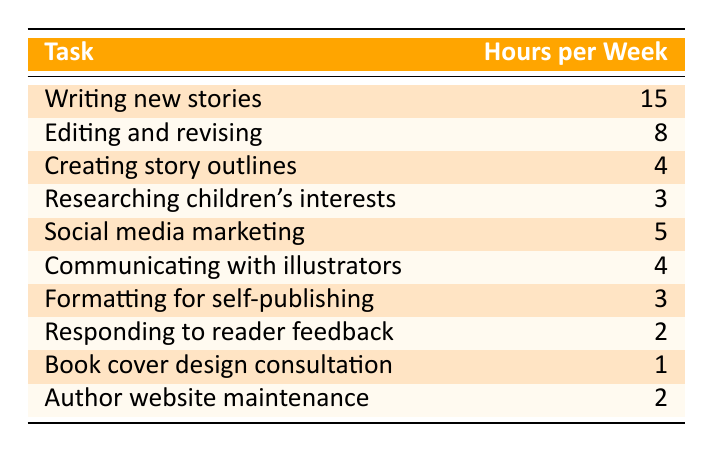What task requires the most hours per week? Referring to the table, the task with the highest hours is "Writing new stories," which takes 15 hours per week.
Answer: 15 hours How many hours do you spend on editing and revising each week? The table indicates that "Editing and revising" takes 8 hours per week.
Answer: 8 hours What is the combined time spent on creating story outlines and formatting for self-publishing? "Creating story outlines" takes 4 hours, and "Formatting for self-publishing" takes 3 hours, so the total is 4 + 3 = 7 hours.
Answer: 7 hours Is the time spent on social media marketing greater than the time spent on researching children's interests? "Social media marketing" takes 5 hours, while "Researching children's interests" takes 3 hours. Since 5 is greater than 3, the statement is true.
Answer: Yes What is the total time spent on tasks related to communicating with illustrators and responding to reader feedback? "Communicating with illustrators" takes 4 hours and "Responding to reader feedback" takes 2 hours. Adding these gives us 4 + 2 = 6 hours spent on these tasks.
Answer: 6 hours Which task takes the least amount of time per week? The task with the least hours is "Book cover design consultation," which only takes 1 hour per week according to the table.
Answer: 1 hour What is the average time spent on all tasks listed in the table? To find the average, first sum all the hours: 15 + 8 + 4 + 3 + 5 + 4 + 3 + 2 + 1 + 2 = 43 hours. There are 10 tasks total, so the average is 43 / 10 = 4.3 hours.
Answer: 4.3 hours How much more time is spent writing new stories than editing and revising? Writing new stories takes 15 hours while editing and revising takes 8 hours. The difference is 15 - 8 = 7 hours.
Answer: 7 hours Is the total time spent on author website maintenance greater than the time spent on book cover design consultation? "Author website maintenance" takes 2 hours and "Book cover design consultation" takes 1 hour. Since 2 is greater than 1, the statement is true.
Answer: Yes 